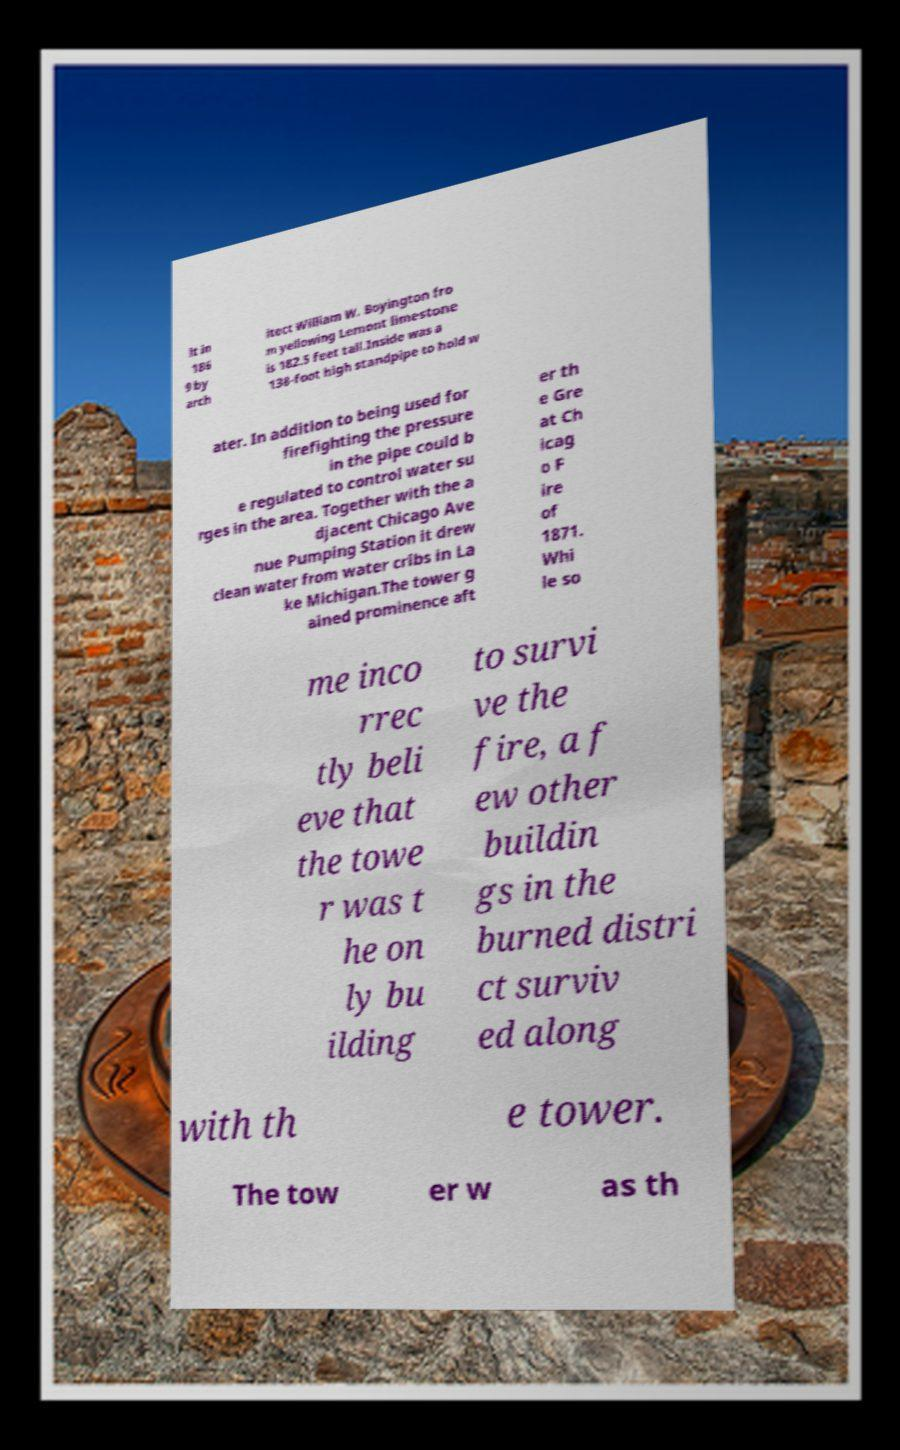Can you accurately transcribe the text from the provided image for me? lt in 186 9 by arch itect William W. Boyington fro m yellowing Lemont limestone is 182.5 feet tall.Inside was a 138-foot high standpipe to hold w ater. In addition to being used for firefighting the pressure in the pipe could b e regulated to control water su rges in the area. Together with the a djacent Chicago Ave nue Pumping Station it drew clean water from water cribs in La ke Michigan.The tower g ained prominence aft er th e Gre at Ch icag o F ire of 1871. Whi le so me inco rrec tly beli eve that the towe r was t he on ly bu ilding to survi ve the fire, a f ew other buildin gs in the burned distri ct surviv ed along with th e tower. The tow er w as th 